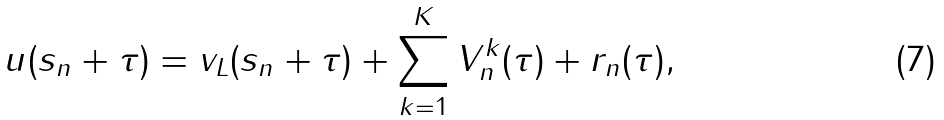Convert formula to latex. <formula><loc_0><loc_0><loc_500><loc_500>u ( s _ { n } + \tau ) = v _ { L } ( s _ { n } + \tau ) + \sum _ { k = 1 } ^ { K } V _ { n } ^ { k } ( \tau ) + r _ { n } ( \tau ) ,</formula> 